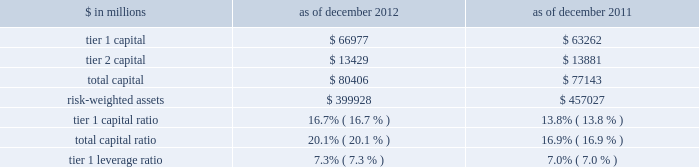Notes to consolidated financial statements note 20 .
Regulation and capital adequacy the federal reserve board is the primary regulator of group inc. , a bank holding company under the bank holding company act of 1956 ( bhc act ) and a financial holding company under amendments to the bhc act effected by the u.s .
Gramm-leach-bliley act of 1999 .
As a bank holding company , the firm is subject to consolidated regulatory capital requirements that are computed in accordance with the federal reserve board 2019s risk-based capital requirements ( which are based on the 2018basel 1 2019 capital accord of the basel committee ) .
These capital requirements are expressed as capital ratios that compare measures of capital to risk-weighted assets ( rwas ) .
The firm 2019s u.s .
Bank depository institution subsidiaries , including gs bank usa , are subject to similar capital requirements .
Under the federal reserve board 2019s capital adequacy requirements and the regulatory framework for prompt corrective action that is applicable to gs bank usa , the firm and its u.s .
Bank depository institution subsidiaries must meet specific capital requirements that involve quantitative measures of assets , liabilities and certain off- balance-sheet items as calculated under regulatory reporting practices .
The firm and its u.s .
Bank depository institution subsidiaries 2019 capital amounts , as well as gs bank usa 2019s prompt corrective action classification , are also subject to qualitative judgments by the regulators about components , risk weightings and other factors .
Many of the firm 2019s subsidiaries , including gs&co .
And the firm 2019s other broker-dealer subsidiaries , are subject to separate regulation and capital requirements as described below .
Group inc .
Federal reserve board regulations require bank holding companies to maintain a minimum tier 1 capital ratio of 4% ( 4 % ) and a minimum total capital ratio of 8% ( 8 % ) .
The required minimum tier 1 capital ratio and total capital ratio in order to be considered a 201cwell-capitalized 201d bank holding company under the federal reserve board guidelines are 6% ( 6 % ) and 10% ( 10 % ) , respectively .
Bank holding companies may be expected to maintain ratios well above the minimum levels , depending on their particular condition , risk profile and growth plans .
The minimum tier 1 leverage ratio is 3% ( 3 % ) for bank holding companies that have received the highest supervisory rating under federal reserve board guidelines or that have implemented the federal reserve board 2019s risk-based capital measure for market risk .
Other bank holding companies must have a minimum tier 1 leverage ratio of 4% ( 4 % ) .
The table below presents information regarding group inc . 2019s regulatory capital ratios. .
Rwas under the federal reserve board 2019s risk-based capital requirements are calculated based on the amount of market risk and credit risk .
Rwas for market risk are determined by reference to the firm 2019s value-at-risk ( var ) model , supplemented by other measures to capture risks not reflected in the firm 2019s var model .
Credit risk for on- balance sheet assets is based on the balance sheet value .
For off-balance sheet exposures , including otc derivatives and commitments , a credit equivalent amount is calculated based on the notional amount of each trade .
All such assets and exposures are then assigned a risk weight depending on , among other things , whether the counterparty is a sovereign , bank or a qualifying securities firm or other entity ( or if collateral is held , depending on the nature of the collateral ) .
Tier 1 leverage ratio is defined as tier 1 capital under basel 1 divided by average adjusted total assets ( which includes adjustments for disallowed goodwill and intangible assets , and the carrying value of equity investments in non-financial companies that are subject to deductions from tier 1 capital ) .
184 goldman sachs 2012 annual report .
What was the change in risk-weighted assets in millions between 2011 and 2012? 
Computations: (399928 - 457027)
Answer: -57099.0. 